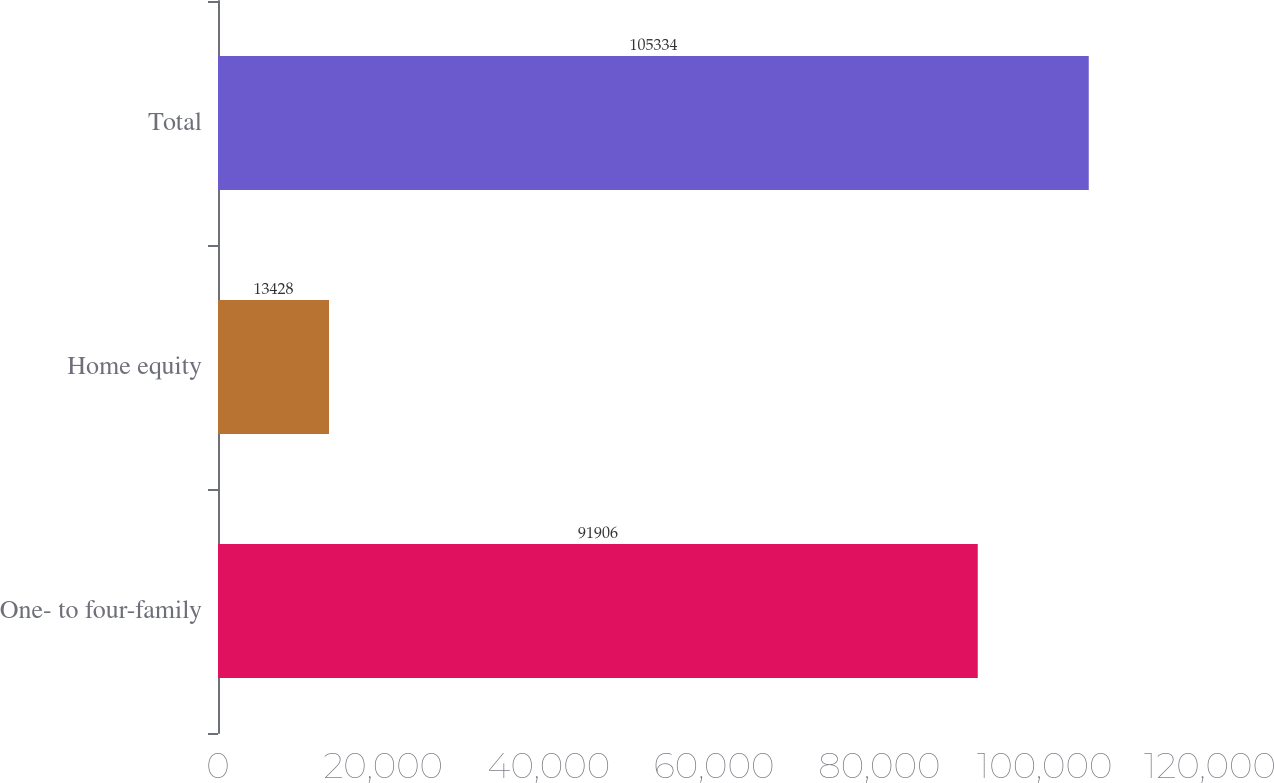Convert chart to OTSL. <chart><loc_0><loc_0><loc_500><loc_500><bar_chart><fcel>One- to four-family<fcel>Home equity<fcel>Total<nl><fcel>91906<fcel>13428<fcel>105334<nl></chart> 